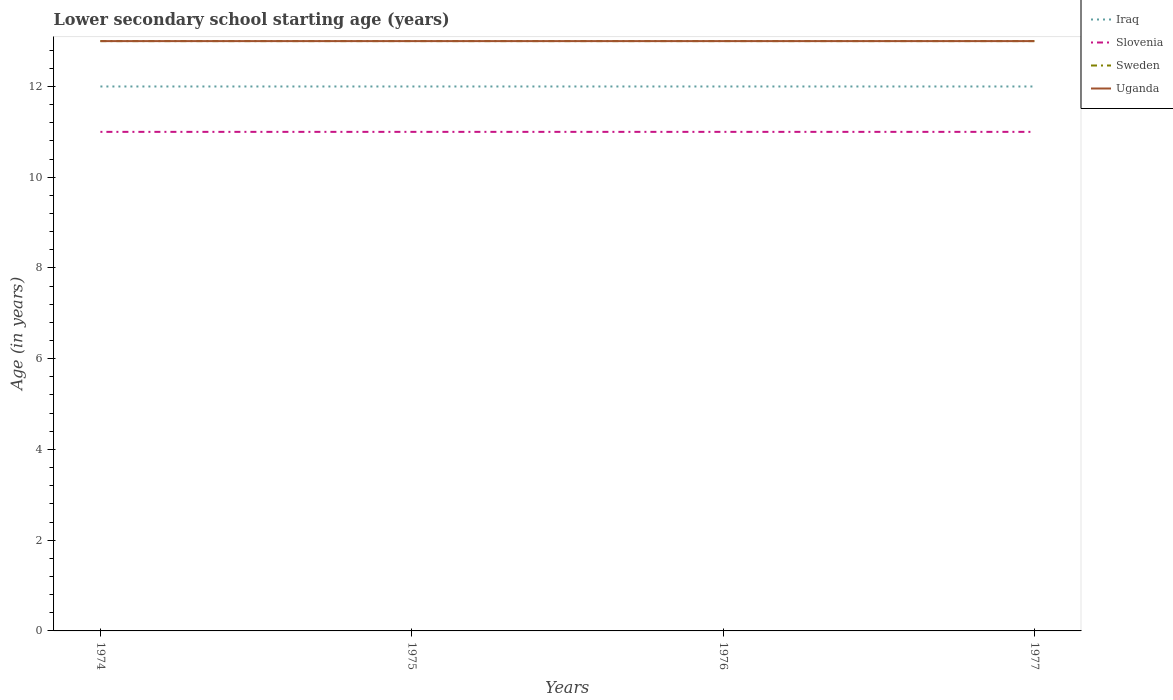How many different coloured lines are there?
Keep it short and to the point. 4. Is the number of lines equal to the number of legend labels?
Offer a very short reply. Yes. Across all years, what is the maximum lower secondary school starting age of children in Uganda?
Offer a very short reply. 13. In which year was the lower secondary school starting age of children in Slovenia maximum?
Offer a very short reply. 1974. What is the total lower secondary school starting age of children in Iraq in the graph?
Your answer should be compact. 0. Is the lower secondary school starting age of children in Sweden strictly greater than the lower secondary school starting age of children in Slovenia over the years?
Provide a succinct answer. No. Are the values on the major ticks of Y-axis written in scientific E-notation?
Provide a short and direct response. No. Does the graph contain any zero values?
Give a very brief answer. No. Does the graph contain grids?
Ensure brevity in your answer.  No. Where does the legend appear in the graph?
Your answer should be very brief. Top right. What is the title of the graph?
Offer a very short reply. Lower secondary school starting age (years). What is the label or title of the Y-axis?
Keep it short and to the point. Age (in years). What is the Age (in years) of Slovenia in 1974?
Give a very brief answer. 11. What is the Age (in years) of Sweden in 1974?
Give a very brief answer. 13. What is the Age (in years) in Slovenia in 1975?
Provide a short and direct response. 11. What is the Age (in years) of Sweden in 1975?
Keep it short and to the point. 13. What is the Age (in years) of Uganda in 1975?
Provide a short and direct response. 13. What is the Age (in years) in Iraq in 1976?
Provide a succinct answer. 12. What is the Age (in years) in Iraq in 1977?
Provide a short and direct response. 12. What is the Age (in years) in Uganda in 1977?
Your answer should be compact. 13. Across all years, what is the maximum Age (in years) in Slovenia?
Provide a short and direct response. 11. Across all years, what is the maximum Age (in years) in Sweden?
Provide a succinct answer. 13. Across all years, what is the minimum Age (in years) in Iraq?
Give a very brief answer. 12. Across all years, what is the minimum Age (in years) of Slovenia?
Your answer should be compact. 11. Across all years, what is the minimum Age (in years) in Sweden?
Ensure brevity in your answer.  13. What is the total Age (in years) of Sweden in the graph?
Your response must be concise. 52. What is the total Age (in years) of Uganda in the graph?
Offer a very short reply. 52. What is the difference between the Age (in years) in Iraq in 1974 and that in 1975?
Provide a succinct answer. 0. What is the difference between the Age (in years) of Uganda in 1974 and that in 1975?
Your response must be concise. 0. What is the difference between the Age (in years) in Iraq in 1974 and that in 1976?
Your answer should be very brief. 0. What is the difference between the Age (in years) of Sweden in 1974 and that in 1976?
Offer a very short reply. 0. What is the difference between the Age (in years) of Uganda in 1974 and that in 1976?
Make the answer very short. 0. What is the difference between the Age (in years) in Slovenia in 1974 and that in 1977?
Offer a terse response. 0. What is the difference between the Age (in years) of Sweden in 1974 and that in 1977?
Ensure brevity in your answer.  0. What is the difference between the Age (in years) in Uganda in 1974 and that in 1977?
Make the answer very short. 0. What is the difference between the Age (in years) in Iraq in 1975 and that in 1976?
Ensure brevity in your answer.  0. What is the difference between the Age (in years) of Slovenia in 1975 and that in 1977?
Provide a short and direct response. 0. What is the difference between the Age (in years) of Sweden in 1975 and that in 1977?
Your response must be concise. 0. What is the difference between the Age (in years) of Uganda in 1975 and that in 1977?
Your answer should be compact. 0. What is the difference between the Age (in years) of Slovenia in 1976 and that in 1977?
Make the answer very short. 0. What is the difference between the Age (in years) in Iraq in 1974 and the Age (in years) in Sweden in 1975?
Provide a short and direct response. -1. What is the difference between the Age (in years) of Iraq in 1974 and the Age (in years) of Uganda in 1975?
Provide a succinct answer. -1. What is the difference between the Age (in years) in Iraq in 1974 and the Age (in years) in Sweden in 1976?
Offer a very short reply. -1. What is the difference between the Age (in years) in Iraq in 1974 and the Age (in years) in Uganda in 1976?
Your answer should be compact. -1. What is the difference between the Age (in years) of Slovenia in 1974 and the Age (in years) of Uganda in 1976?
Give a very brief answer. -2. What is the difference between the Age (in years) of Sweden in 1974 and the Age (in years) of Uganda in 1976?
Keep it short and to the point. 0. What is the difference between the Age (in years) in Iraq in 1974 and the Age (in years) in Sweden in 1977?
Provide a short and direct response. -1. What is the difference between the Age (in years) in Iraq in 1974 and the Age (in years) in Uganda in 1977?
Your answer should be very brief. -1. What is the difference between the Age (in years) of Slovenia in 1974 and the Age (in years) of Sweden in 1977?
Your answer should be very brief. -2. What is the difference between the Age (in years) of Iraq in 1975 and the Age (in years) of Sweden in 1976?
Keep it short and to the point. -1. What is the difference between the Age (in years) of Iraq in 1975 and the Age (in years) of Uganda in 1976?
Your response must be concise. -1. What is the difference between the Age (in years) in Sweden in 1975 and the Age (in years) in Uganda in 1977?
Offer a terse response. 0. What is the difference between the Age (in years) in Iraq in 1976 and the Age (in years) in Slovenia in 1977?
Your response must be concise. 1. What is the difference between the Age (in years) of Iraq in 1976 and the Age (in years) of Uganda in 1977?
Provide a succinct answer. -1. What is the difference between the Age (in years) of Slovenia in 1976 and the Age (in years) of Uganda in 1977?
Give a very brief answer. -2. In the year 1974, what is the difference between the Age (in years) of Iraq and Age (in years) of Uganda?
Offer a very short reply. -1. In the year 1974, what is the difference between the Age (in years) in Sweden and Age (in years) in Uganda?
Offer a terse response. 0. In the year 1975, what is the difference between the Age (in years) in Iraq and Age (in years) in Slovenia?
Ensure brevity in your answer.  1. In the year 1976, what is the difference between the Age (in years) in Iraq and Age (in years) in Sweden?
Keep it short and to the point. -1. In the year 1976, what is the difference between the Age (in years) in Slovenia and Age (in years) in Sweden?
Offer a terse response. -2. In the year 1976, what is the difference between the Age (in years) in Sweden and Age (in years) in Uganda?
Provide a succinct answer. 0. In the year 1977, what is the difference between the Age (in years) in Iraq and Age (in years) in Sweden?
Provide a short and direct response. -1. In the year 1977, what is the difference between the Age (in years) in Iraq and Age (in years) in Uganda?
Provide a succinct answer. -1. In the year 1977, what is the difference between the Age (in years) in Sweden and Age (in years) in Uganda?
Ensure brevity in your answer.  0. What is the ratio of the Age (in years) of Iraq in 1974 to that in 1975?
Ensure brevity in your answer.  1. What is the ratio of the Age (in years) of Sweden in 1974 to that in 1975?
Make the answer very short. 1. What is the ratio of the Age (in years) of Uganda in 1974 to that in 1975?
Make the answer very short. 1. What is the ratio of the Age (in years) of Iraq in 1974 to that in 1976?
Offer a terse response. 1. What is the ratio of the Age (in years) of Slovenia in 1974 to that in 1976?
Offer a very short reply. 1. What is the ratio of the Age (in years) in Sweden in 1974 to that in 1976?
Offer a very short reply. 1. What is the ratio of the Age (in years) of Sweden in 1974 to that in 1977?
Ensure brevity in your answer.  1. What is the ratio of the Age (in years) in Uganda in 1974 to that in 1977?
Provide a short and direct response. 1. What is the ratio of the Age (in years) of Iraq in 1975 to that in 1976?
Your answer should be compact. 1. What is the ratio of the Age (in years) of Uganda in 1975 to that in 1976?
Offer a very short reply. 1. What is the ratio of the Age (in years) of Slovenia in 1975 to that in 1977?
Ensure brevity in your answer.  1. What is the ratio of the Age (in years) in Sweden in 1975 to that in 1977?
Offer a very short reply. 1. What is the ratio of the Age (in years) in Uganda in 1976 to that in 1977?
Offer a very short reply. 1. What is the difference between the highest and the second highest Age (in years) of Iraq?
Keep it short and to the point. 0. What is the difference between the highest and the second highest Age (in years) in Sweden?
Your answer should be very brief. 0. What is the difference between the highest and the lowest Age (in years) of Sweden?
Your response must be concise. 0. 